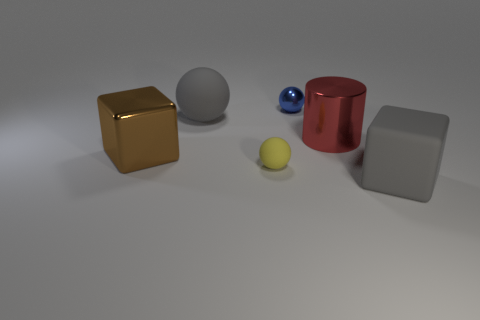What is the size of the matte ball that is the same color as the big matte block?
Provide a short and direct response. Large. The large matte sphere has what color?
Offer a very short reply. Gray. There is a big object that is behind the large rubber cube and to the right of the tiny blue object; what is its color?
Keep it short and to the point. Red. The big rubber thing behind the big block that is left of the sphere that is right of the yellow rubber ball is what color?
Keep it short and to the point. Gray. The ball that is the same size as the red object is what color?
Offer a very short reply. Gray. What shape is the big metal thing that is to the left of the tiny ball behind the rubber sphere that is behind the brown metallic object?
Offer a very short reply. Cube. There is a large thing that is the same color as the big matte ball; what is its shape?
Provide a succinct answer. Cube. How many objects are either tiny gray spheres or things that are behind the yellow sphere?
Offer a terse response. 4. Is the size of the block to the right of the red metallic thing the same as the tiny yellow ball?
Give a very brief answer. No. What is the gray object that is right of the tiny blue shiny thing made of?
Ensure brevity in your answer.  Rubber. 